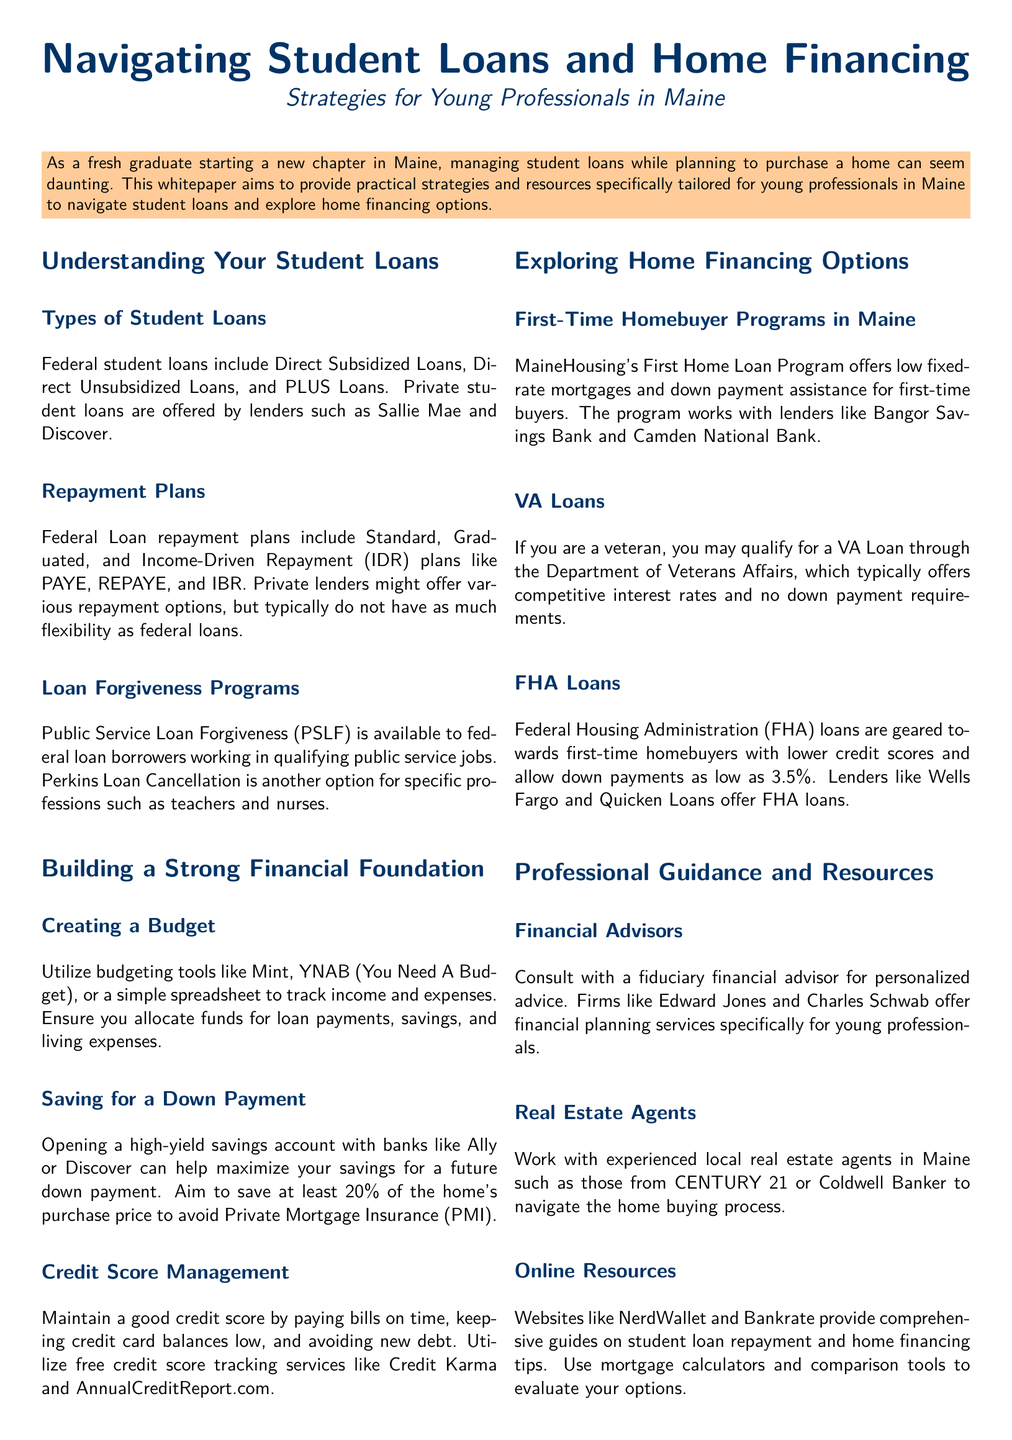What are the types of federal student loans? The document lists the federal student loans as Direct Subsidized Loans, Direct Unsubsidized Loans, and PLUS Loans.
Answer: Direct Subsidized Loans, Direct Unsubsidized Loans, and PLUS Loans What is the main purpose of this whitepaper? The whitepaper aims to provide practical strategies and resources for young professionals in Maine to manage student loans and explore home financing options.
Answer: To provide practical strategies and resources Which program offers low fixed-rate mortgages for first-time homebuyers in Maine? The document mentions MaineHousing's First Home Loan Program as providing low fixed-rate mortgages and down payment assistance.
Answer: MaineHousing's First Home Loan Program What is one recommended tool for tracking expenses? The whitepaper suggests utilizing budgeting tools like Mint or YNAB to track income and expenses.
Answer: Mint or YNAB What down payment percentage is suggested to avoid Private Mortgage Insurance? The document states that saving at least 20% of the home's purchase price is recommended to avoid Private Mortgage Insurance.
Answer: 20% Which loan type is geared towards first-time homebuyers with lower credit scores? The whitepaper identifies FHA loans as being aimed at first-time homebuyers with lower credit scores.
Answer: FHA loans What financial advice is suggested for managing credit scores? The document advises maintaining a good credit score by paying bills on time and keeping credit card balances low.
Answer: Pay bills on time and keep credit card balances low What service do fiduciary financial advisors offer? The whitepaper states fiduciary financial advisors provide personalized financial advice for young professionals.
Answer: Personalized financial advice 